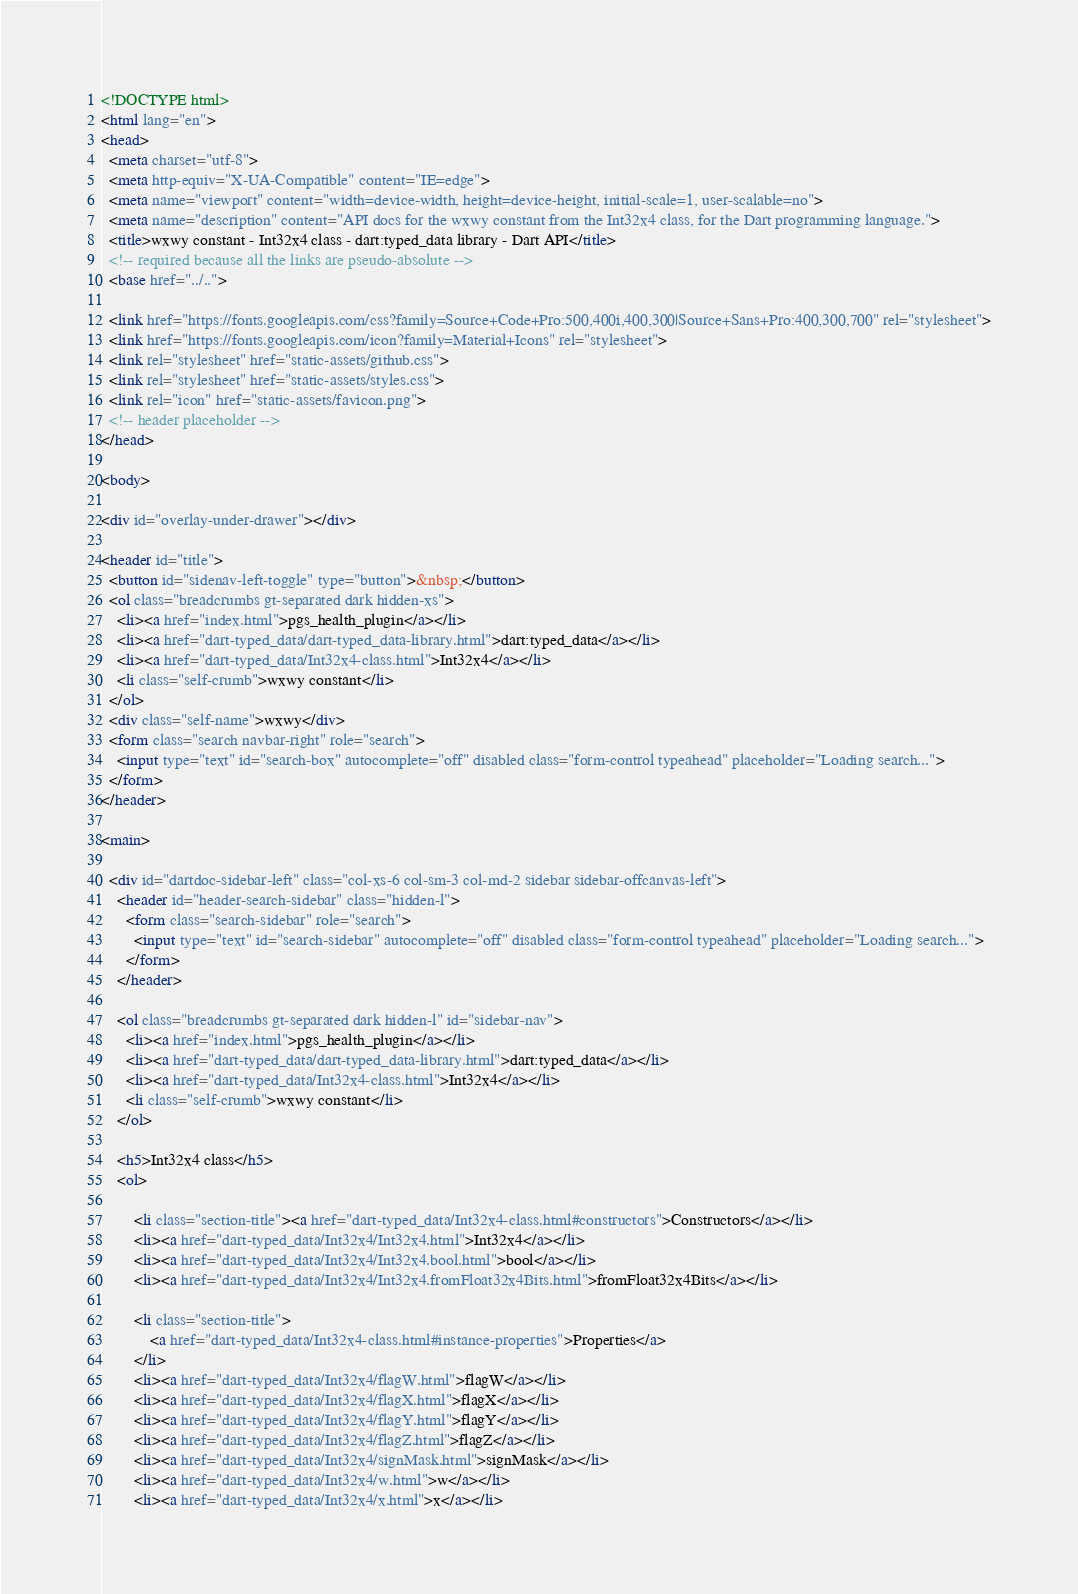Convert code to text. <code><loc_0><loc_0><loc_500><loc_500><_HTML_><!DOCTYPE html>
<html lang="en">
<head>
  <meta charset="utf-8">
  <meta http-equiv="X-UA-Compatible" content="IE=edge">
  <meta name="viewport" content="width=device-width, height=device-height, initial-scale=1, user-scalable=no">
  <meta name="description" content="API docs for the wxwy constant from the Int32x4 class, for the Dart programming language.">
  <title>wxwy constant - Int32x4 class - dart:typed_data library - Dart API</title>
  <!-- required because all the links are pseudo-absolute -->
  <base href="../..">

  <link href="https://fonts.googleapis.com/css?family=Source+Code+Pro:500,400i,400,300|Source+Sans+Pro:400,300,700" rel="stylesheet">
  <link href="https://fonts.googleapis.com/icon?family=Material+Icons" rel="stylesheet">
  <link rel="stylesheet" href="static-assets/github.css">
  <link rel="stylesheet" href="static-assets/styles.css">
  <link rel="icon" href="static-assets/favicon.png">
  <!-- header placeholder -->
</head>

<body>

<div id="overlay-under-drawer"></div>

<header id="title">
  <button id="sidenav-left-toggle" type="button">&nbsp;</button>
  <ol class="breadcrumbs gt-separated dark hidden-xs">
    <li><a href="index.html">pgs_health_plugin</a></li>
    <li><a href="dart-typed_data/dart-typed_data-library.html">dart:typed_data</a></li>
    <li><a href="dart-typed_data/Int32x4-class.html">Int32x4</a></li>
    <li class="self-crumb">wxwy constant</li>
  </ol>
  <div class="self-name">wxwy</div>
  <form class="search navbar-right" role="search">
    <input type="text" id="search-box" autocomplete="off" disabled class="form-control typeahead" placeholder="Loading search...">
  </form>
</header>

<main>

  <div id="dartdoc-sidebar-left" class="col-xs-6 col-sm-3 col-md-2 sidebar sidebar-offcanvas-left">
    <header id="header-search-sidebar" class="hidden-l">
      <form class="search-sidebar" role="search">
        <input type="text" id="search-sidebar" autocomplete="off" disabled class="form-control typeahead" placeholder="Loading search...">
      </form>
    </header>
    
    <ol class="breadcrumbs gt-separated dark hidden-l" id="sidebar-nav">
      <li><a href="index.html">pgs_health_plugin</a></li>
      <li><a href="dart-typed_data/dart-typed_data-library.html">dart:typed_data</a></li>
      <li><a href="dart-typed_data/Int32x4-class.html">Int32x4</a></li>
      <li class="self-crumb">wxwy constant</li>
    </ol>
    
    <h5>Int32x4 class</h5>
    <ol>
    
        <li class="section-title"><a href="dart-typed_data/Int32x4-class.html#constructors">Constructors</a></li>
        <li><a href="dart-typed_data/Int32x4/Int32x4.html">Int32x4</a></li>
        <li><a href="dart-typed_data/Int32x4/Int32x4.bool.html">bool</a></li>
        <li><a href="dart-typed_data/Int32x4/Int32x4.fromFloat32x4Bits.html">fromFloat32x4Bits</a></li>
    
        <li class="section-title">
            <a href="dart-typed_data/Int32x4-class.html#instance-properties">Properties</a>
        </li>
        <li><a href="dart-typed_data/Int32x4/flagW.html">flagW</a></li>
        <li><a href="dart-typed_data/Int32x4/flagX.html">flagX</a></li>
        <li><a href="dart-typed_data/Int32x4/flagY.html">flagY</a></li>
        <li><a href="dart-typed_data/Int32x4/flagZ.html">flagZ</a></li>
        <li><a href="dart-typed_data/Int32x4/signMask.html">signMask</a></li>
        <li><a href="dart-typed_data/Int32x4/w.html">w</a></li>
        <li><a href="dart-typed_data/Int32x4/x.html">x</a></li></code> 